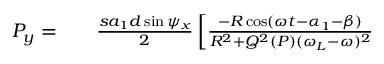<formula> <loc_0><loc_0><loc_500><loc_500>\begin{array} { r l r } { P _ { y } = } & { \frac { s a _ { 1 } d \sin \psi _ { x } } { 2 } \left [ \frac { - R \cos ( \omega t - \alpha _ { 1 } - \beta ) } { R ^ { 2 } + Q ^ { 2 } ( P ) ( \omega _ { L } - \omega ) ^ { 2 } } } \end{array}</formula> 